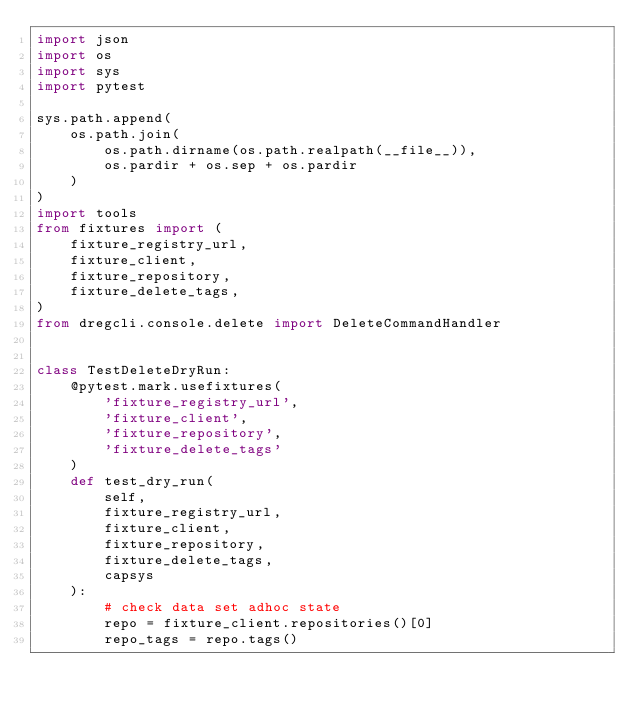<code> <loc_0><loc_0><loc_500><loc_500><_Python_>import json
import os
import sys
import pytest

sys.path.append(
    os.path.join(
        os.path.dirname(os.path.realpath(__file__)),
        os.pardir + os.sep + os.pardir
    )
)
import tools
from fixtures import (
    fixture_registry_url,
    fixture_client,
    fixture_repository,
    fixture_delete_tags,
)
from dregcli.console.delete import DeleteCommandHandler


class TestDeleteDryRun:
    @pytest.mark.usefixtures(
        'fixture_registry_url',
        'fixture_client',
        'fixture_repository',
        'fixture_delete_tags'
    )
    def test_dry_run(
        self,
        fixture_registry_url,
        fixture_client,
        fixture_repository,
        fixture_delete_tags,
        capsys
    ):
        # check data set adhoc state
        repo = fixture_client.repositories()[0]
        repo_tags = repo.tags()</code> 